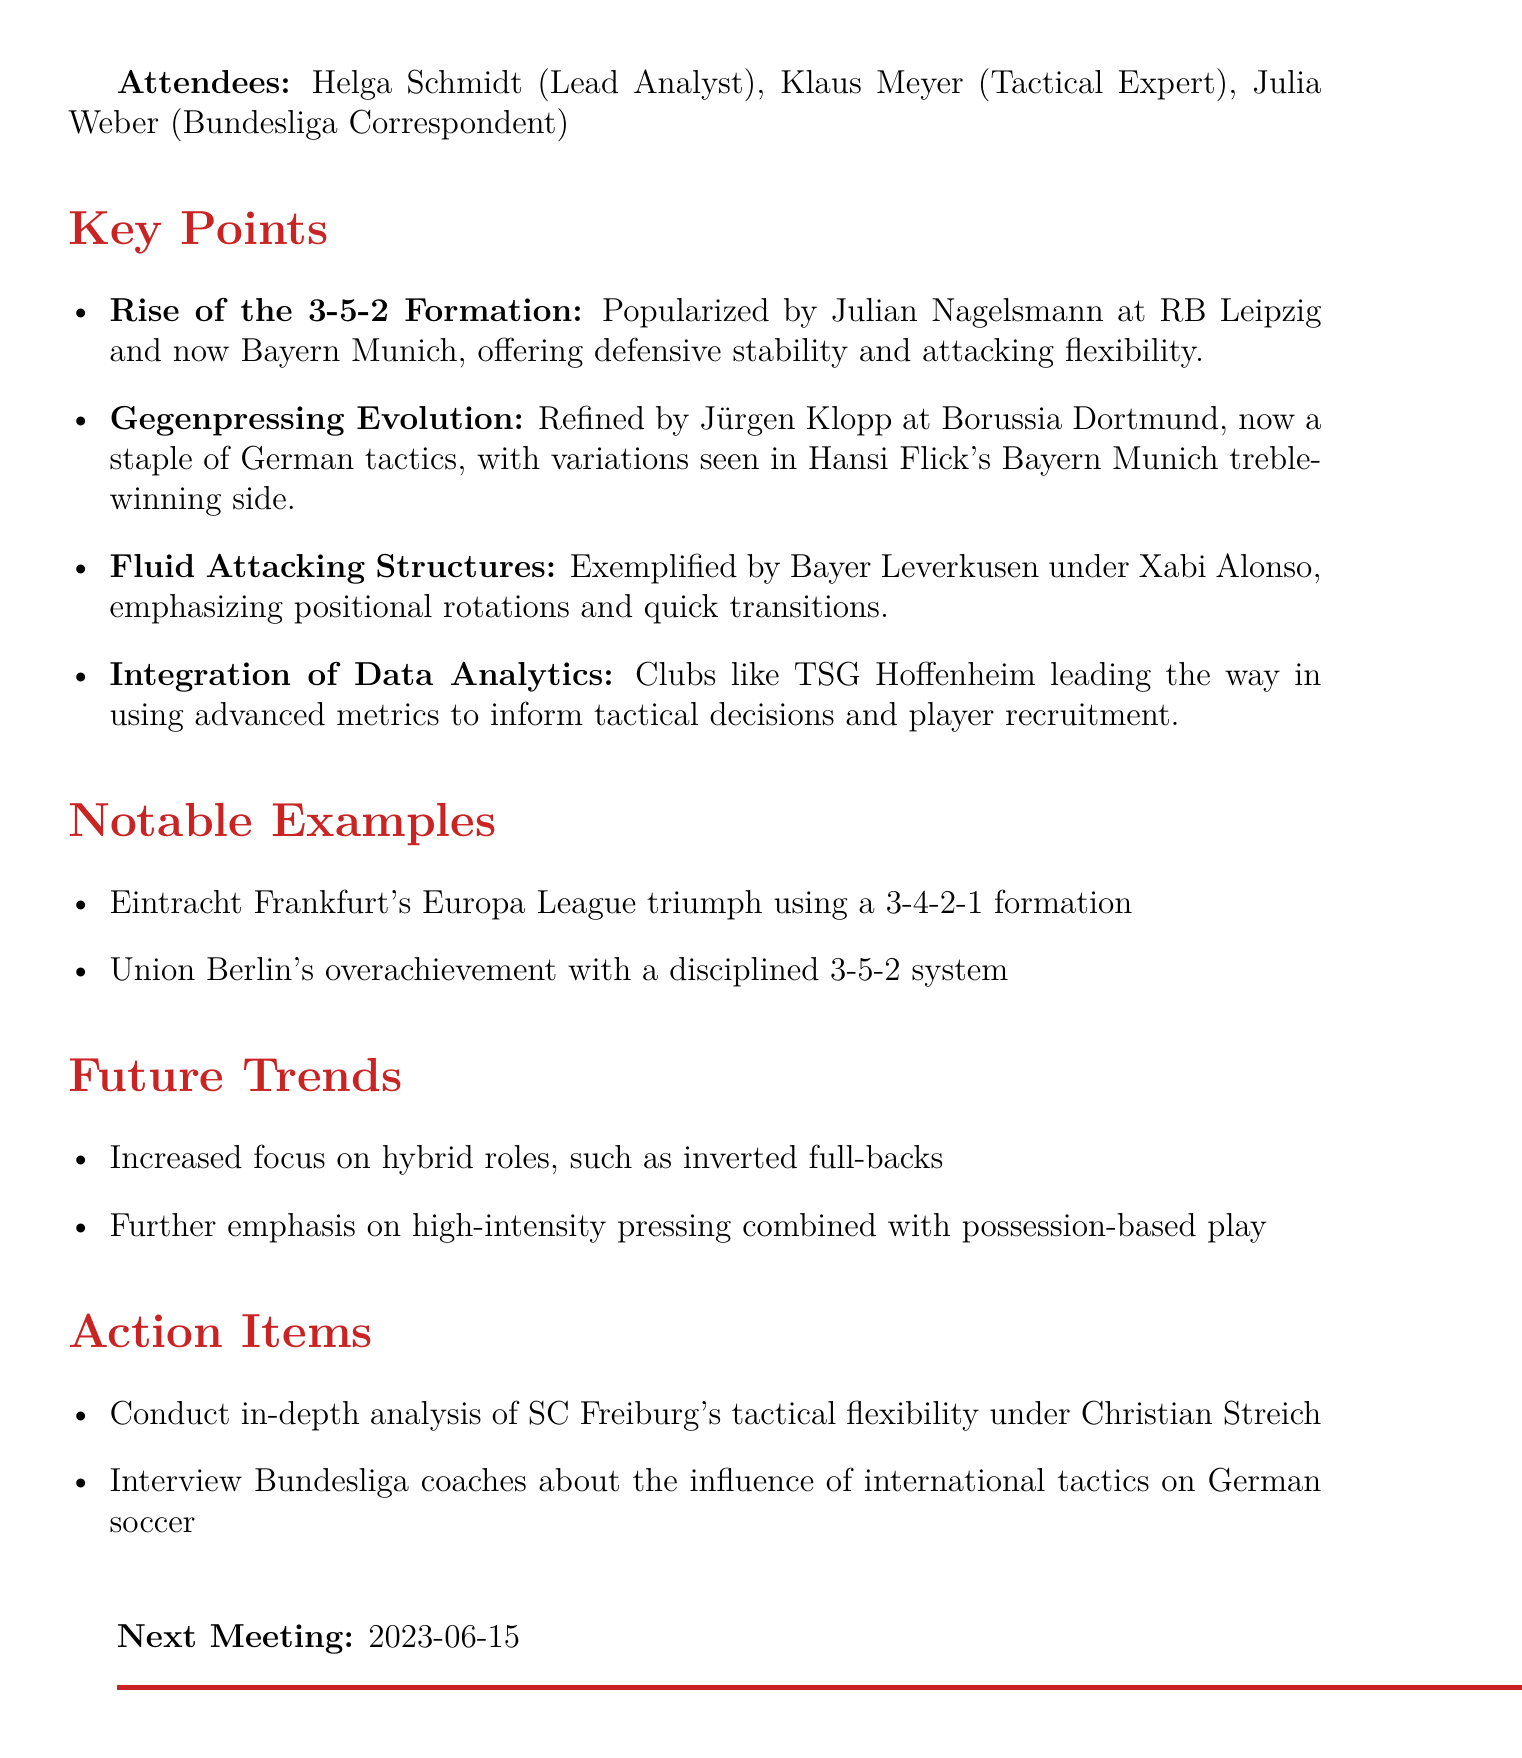What was the date of the meeting? The date of the meeting is explicitly stated at the beginning of the document.
Answer: 2023-05-15 Who popularized the 3-5-2 formation? The document mentions Julian Nagelsmann as the one who popularized the 3-5-2 formation at RB Leipzig and Bayern Munich.
Answer: Julian Nagelsmann Which club exemplifies fluid attacking structures under Xabi Alonso? The document identifies Bayer Leverkusen as the club that exemplifies fluid attacking structures under Xabi Alonso.
Answer: Bayer Leverkusen What tactical trend is associated with Jürgen Klopp? The document states that Gegenpressing is the tactical trend associated with Jürgen Klopp.
Answer: Gegenpressing What is one notable example of a successful formation used in a recent competition? The document provides the example of Eintracht Frankfurt's triumph using a specific formation in the Europa League.
Answer: 3-4-2-1 formation What future trend involves the use of inverted full-backs? The increased focus on hybrid roles, such as inverted full-backs, is mentioned as a future trend.
Answer: Hybrid roles What is one action item for the next meeting? The document outlines conducting an in-depth analysis of SC Freiburg's tactical flexibility as one action item.
Answer: Analyze SC Freiburg's tactical flexibility When is the next meeting scheduled? The document clearly states the date of the next meeting.
Answer: 2023-06-15 